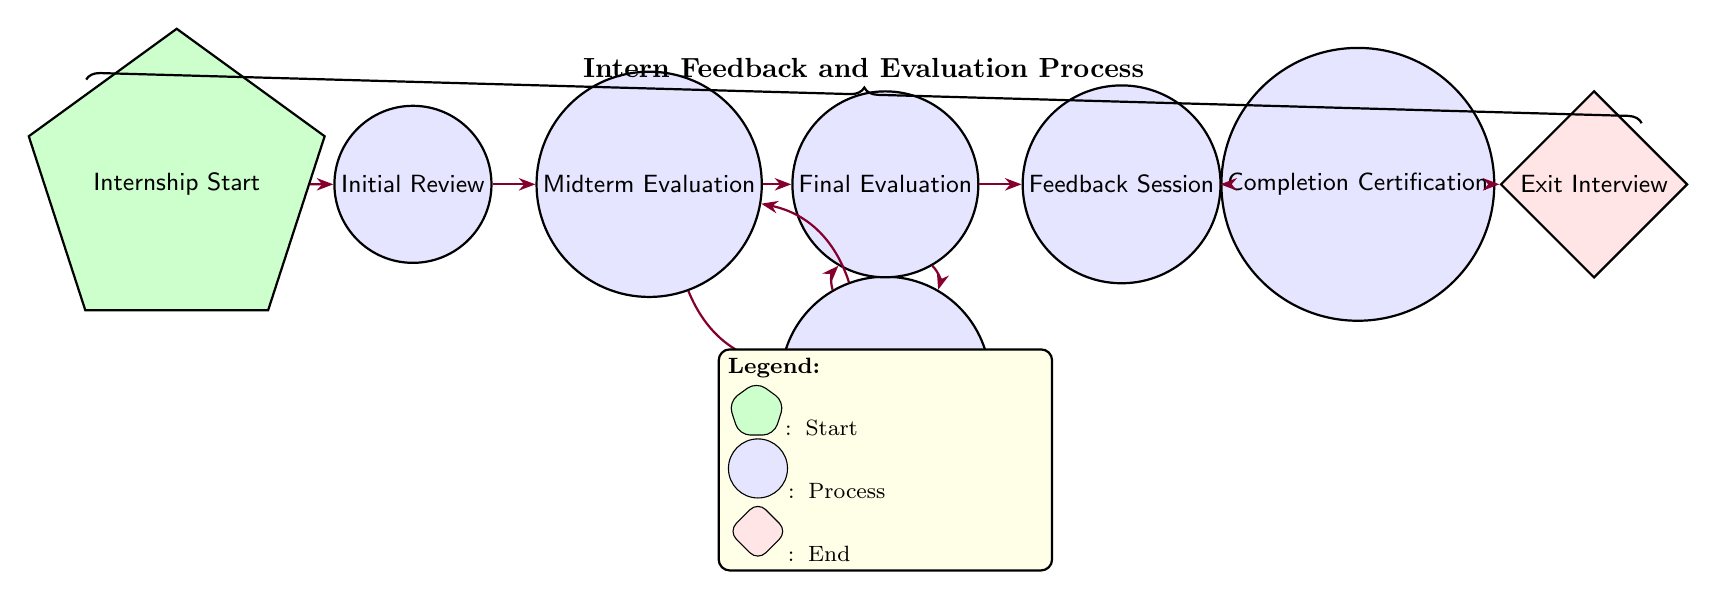What is the starting node of the process? The starting node is labeled as "Internship Start." This is the first state in the diagram from which all evaluations proceed.
Answer: Internship Start How many nodes are there in the diagram? To find the number of nodes, we can count all the states listed: "Internship Start," "Initial Review," "Midterm Evaluation," "Final Evaluation," "Feedback Session," "Improvement Plan," "Completion Certification," and "Exit Interview." This gives us a total of 8 nodes.
Answer: 8 What action is taken during the Final Evaluation? The action associated with the Final Evaluation state is to "Conduct final performance assessment and gather overall feedback." This describes the purpose of this state in the evaluation process.
Answer: Conduct final performance assessment and gather overall feedback Which state follows the Midterm Evaluation if no improvement plan is required? If no improvement plan is needed, the transition from Midterm Evaluation proceeds to Final Evaluation directly. This follows the workflow as displayed in the diagram.
Answer: Final Evaluation What is the last node in the process? The last node in the process, which signifies the end of the evaluation workflow, is labeled as "Exit Interview." This is where final thoughts from the intern are collected.
Answer: Exit Interview What happens after the Feedback Session? Following the Feedback Session, the process moves to Completion Certification. This flow indicates that after receiving feedback, the intern may receive a certificate if they meet the requirements.
Answer: Completion Certification Which states allow for a transition back to the Midterm Evaluation? The Improvement Plan state allows for a transition back to Midterm Evaluation, indicating that the intern might require further evaluations after creating an improvement plan.
Answer: Improvement Plan How many transitions lead out from the Initial Review state? From the Initial Review state, there is one transition that leads to the Midterm Evaluation state. This means the Initial Review only forwards to this next state.
Answer: 1 What is assessed during the Midterm Evaluation? During the Midterm Evaluation, the action taken is to evaluate progress and gather feedback from mentors and supervisors. This provides insight into the intern's development thus far.
Answer: Evaluate progress and gather feedback from mentors and supervisors 